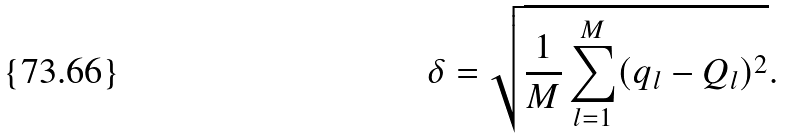Convert formula to latex. <formula><loc_0><loc_0><loc_500><loc_500>\delta = \sqrt { \frac { 1 } { M } \sum _ { l = 1 } ^ { M } ( q _ { l } - Q _ { l } ) ^ { 2 } } .</formula> 